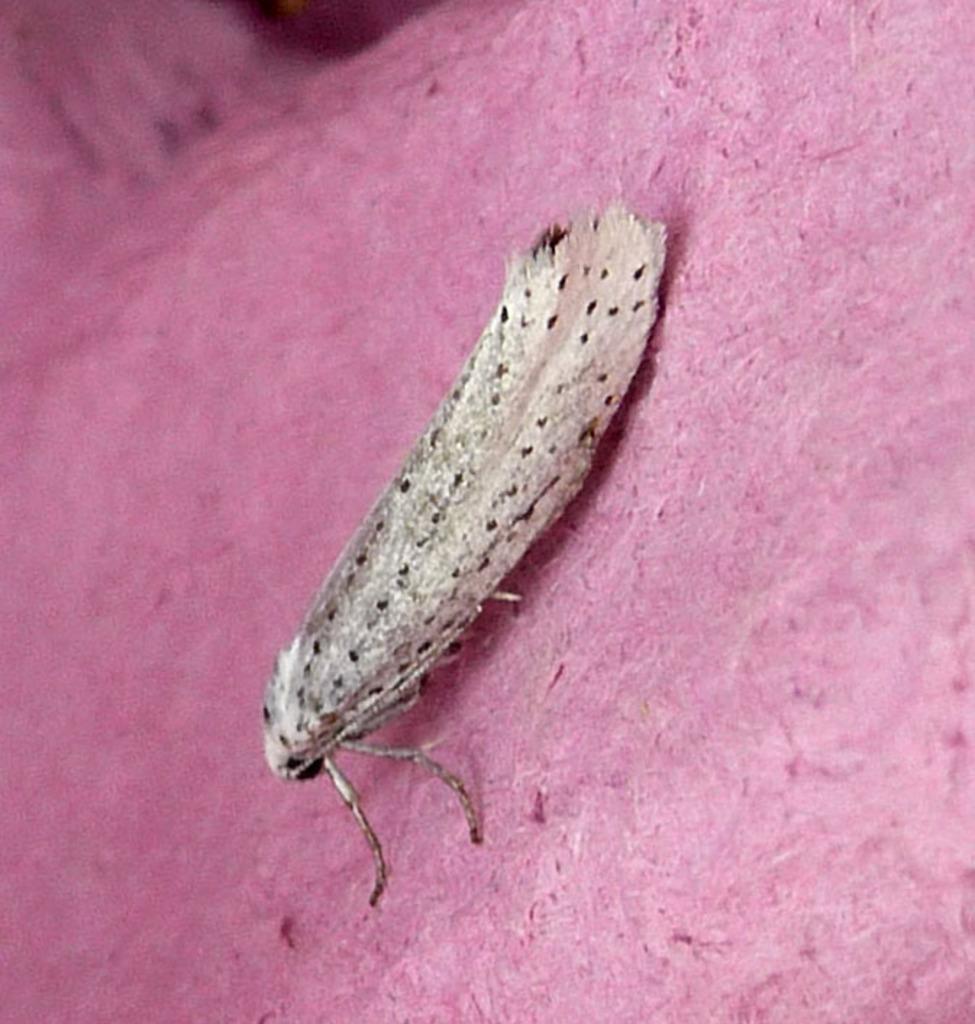Can you describe this image briefly? Here we can see an insect on a pink color object. 